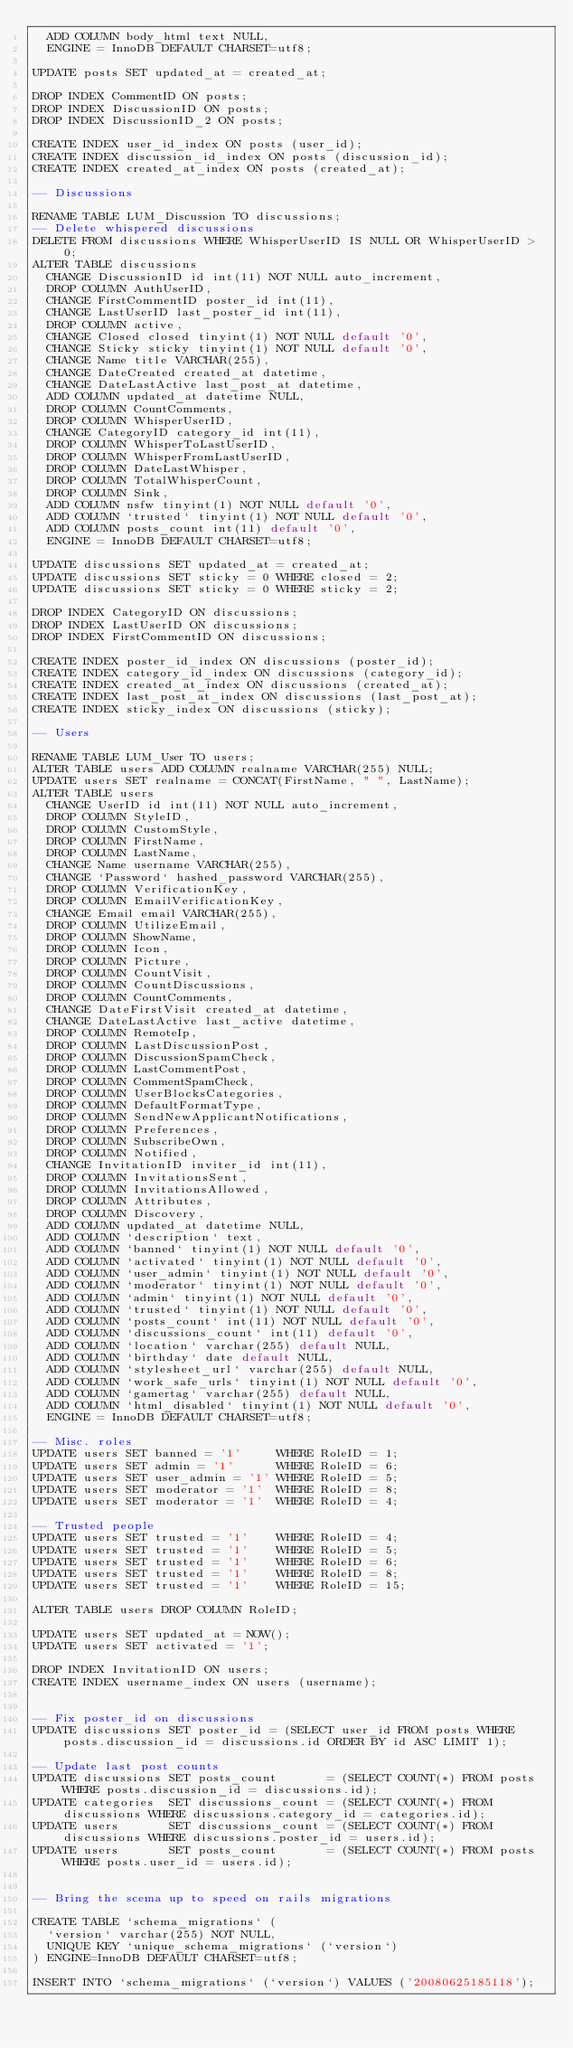<code> <loc_0><loc_0><loc_500><loc_500><_SQL_>  ADD COLUMN body_html text NULL,
  ENGINE = InnoDB DEFAULT CHARSET=utf8;
  
UPDATE posts SET updated_at = created_at;

DROP INDEX CommentID ON posts;
DROP INDEX DiscussionID ON posts;
DROP INDEX DiscussionID_2 ON posts;

CREATE INDEX user_id_index ON posts (user_id);
CREATE INDEX discussion_id_index ON posts (discussion_id);
CREATE INDEX created_at_index ON posts (created_at);

-- Discussions

RENAME TABLE LUM_Discussion TO discussions;
-- Delete whispered discussions
DELETE FROM discussions WHERE WhisperUserID IS NULL OR WhisperUserID > 0;
ALTER TABLE discussions
  CHANGE DiscussionID id int(11) NOT NULL auto_increment,
  DROP COLUMN AuthUserID,
  CHANGE FirstCommentID poster_id int(11),
  CHANGE LastUserID last_poster_id int(11),
  DROP COLUMN active,
  CHANGE Closed closed tinyint(1) NOT NULL default '0',
  CHANGE Sticky sticky tinyint(1) NOT NULL default '0',
  CHANGE Name title VARCHAR(255),
  CHANGE DateCreated created_at datetime,
  CHANGE DateLastActive last_post_at datetime,
  ADD COLUMN updated_at datetime NULL,
  DROP COLUMN CountComments,
  DROP COLUMN WhisperUserID,
  CHANGE CategoryID category_id int(11),
  DROP COLUMN WhisperToLastUserID,
  DROP COLUMN WhisperFromLastUserID,
  DROP COLUMN DateLastWhisper,
  DROP COLUMN TotalWhisperCount,
  DROP COLUMN Sink,
  ADD COLUMN nsfw tinyint(1) NOT NULL default '0',
  ADD COLUMN `trusted` tinyint(1) NOT NULL default '0',
  ADD COLUMN posts_count int(11) default '0',
  ENGINE = InnoDB DEFAULT CHARSET=utf8;

UPDATE discussions SET updated_at = created_at;
UPDATE discussions SET sticky = 0 WHERE closed = 2;
UPDATE discussions SET sticky = 0 WHERE sticky = 2;

DROP INDEX CategoryID ON discussions;
DROP INDEX LastUserID ON discussions;
DROP INDEX FirstCommentID ON discussions;

CREATE INDEX poster_id_index ON discussions (poster_id);
CREATE INDEX category_id_index ON discussions (category_id);
CREATE INDEX created_at_index ON discussions (created_at);
CREATE INDEX last_post_at_index ON discussions (last_post_at);
CREATE INDEX sticky_index ON discussions (sticky);

-- Users

RENAME TABLE LUM_User TO users;
ALTER TABLE users ADD COLUMN realname VARCHAR(255) NULL;
UPDATE users SET realname = CONCAT(FirstName, " ", LastName);
ALTER TABLE users
  CHANGE UserID id int(11) NOT NULL auto_increment,
  DROP COLUMN StyleID,
  DROP COLUMN CustomStyle,
  DROP COLUMN FirstName,
  DROP COLUMN LastName,
  CHANGE Name username VARCHAR(255),
  CHANGE `Password` hashed_password VARCHAR(255),
  DROP COLUMN VerificationKey,
  DROP COLUMN EmailVerificationKey,
  CHANGE Email email VARCHAR(255),
  DROP COLUMN UtilizeEmail,
  DROP COLUMN ShowName,
  DROP COLUMN Icon,
  DROP COLUMN Picture,
  DROP COLUMN CountVisit,
  DROP COLUMN CountDiscussions,
  DROP COLUMN CountComments,
  CHANGE DateFirstVisit created_at datetime,
  CHANGE DateLastActive last_active datetime,
  DROP COLUMN RemoteIp,
  DROP COLUMN LastDiscussionPost,
  DROP COLUMN DiscussionSpamCheck,
  DROP COLUMN LastCommentPost,
  DROP COLUMN CommentSpamCheck,
  DROP COLUMN UserBlocksCategories,
  DROP COLUMN DefaultFormatType,
  DROP COLUMN SendNewApplicantNotifications,
  DROP COLUMN Preferences,
  DROP COLUMN SubscribeOwn,
  DROP COLUMN Notified,
  CHANGE InvitationID inviter_id int(11),
  DROP COLUMN InvitationsSent,
  DROP COLUMN InvitationsAllowed,
  DROP COLUMN Attributes,
  DROP COLUMN Discovery,
  ADD COLUMN updated_at datetime NULL,
  ADD COLUMN `description` text,
  ADD COLUMN `banned` tinyint(1) NOT NULL default '0',
  ADD COLUMN `activated` tinyint(1) NOT NULL default '0',
  ADD COLUMN `user_admin` tinyint(1) NOT NULL default '0',
  ADD COLUMN `moderator` tinyint(1) NOT NULL default '0',
  ADD COLUMN `admin` tinyint(1) NOT NULL default '0',
  ADD COLUMN `trusted` tinyint(1) NOT NULL default '0',
  ADD COLUMN `posts_count` int(11) NOT NULL default '0',
  ADD COLUMN `discussions_count` int(11) default '0',
  ADD COLUMN `location` varchar(255) default NULL,
  ADD COLUMN `birthday` date default NULL,
  ADD COLUMN `stylesheet_url` varchar(255) default NULL,
  ADD COLUMN `work_safe_urls` tinyint(1) NOT NULL default '0',
  ADD COLUMN `gamertag` varchar(255) default NULL,
  ADD COLUMN `html_disabled` tinyint(1) NOT NULL default '0',
  ENGINE = InnoDB DEFAULT CHARSET=utf8;
  
-- Misc. roles
UPDATE users SET banned = '1'     WHERE RoleID = 1;
UPDATE users SET admin = '1'      WHERE RoleID = 6;
UPDATE users SET user_admin = '1' WHERE RoleID = 5;
UPDATE users SET moderator = '1'  WHERE RoleID = 8;
UPDATE users SET moderator = '1'  WHERE RoleID = 4;

-- Trusted people
UPDATE users SET trusted = '1'    WHERE RoleID = 4;
UPDATE users SET trusted = '1'    WHERE RoleID = 5;
UPDATE users SET trusted = '1'    WHERE RoleID = 6;
UPDATE users SET trusted = '1'    WHERE RoleID = 8;
UPDATE users SET trusted = '1'    WHERE RoleID = 15;

ALTER TABLE users DROP COLUMN RoleID;
  
UPDATE users SET updated_at = NOW();
UPDATE users SET activated = '1';

DROP INDEX InvitationID ON users;
CREATE INDEX username_index ON users (username);


-- Fix poster_id on discussions
UPDATE discussions SET poster_id = (SELECT user_id FROM posts WHERE posts.discussion_id = discussions.id ORDER BY id ASC LIMIT 1);

-- Update last post counts
UPDATE discussions SET posts_count       = (SELECT COUNT(*) FROM posts WHERE posts.discussion_id = discussions.id);
UPDATE categories  SET discussions_count = (SELECT COUNT(*) FROM discussions WHERE discussions.category_id = categories.id);
UPDATE users       SET discussions_count = (SELECT COUNT(*) FROM discussions WHERE discussions.poster_id = users.id);
UPDATE users       SET posts_count       = (SELECT COUNT(*) FROM posts WHERE posts.user_id = users.id);


-- Bring the scema up to speed on rails migrations

CREATE TABLE `schema_migrations` (
  `version` varchar(255) NOT NULL,
  UNIQUE KEY `unique_schema_migrations` (`version`)
) ENGINE=InnoDB DEFAULT CHARSET=utf8;

INSERT INTO `schema_migrations` (`version`) VALUES ('20080625185118');</code> 